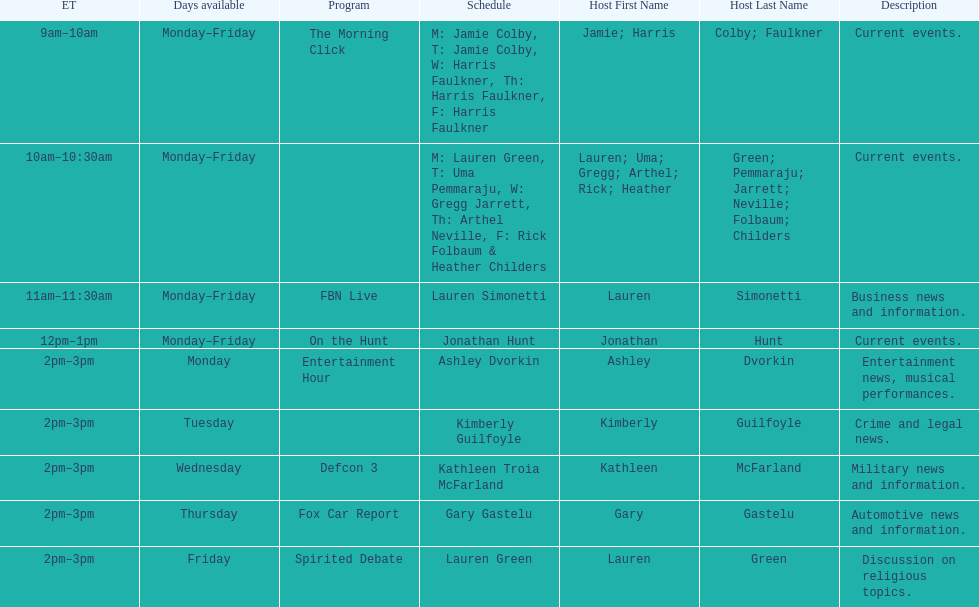Which program is only available on thursdays? Fox Car Report. 